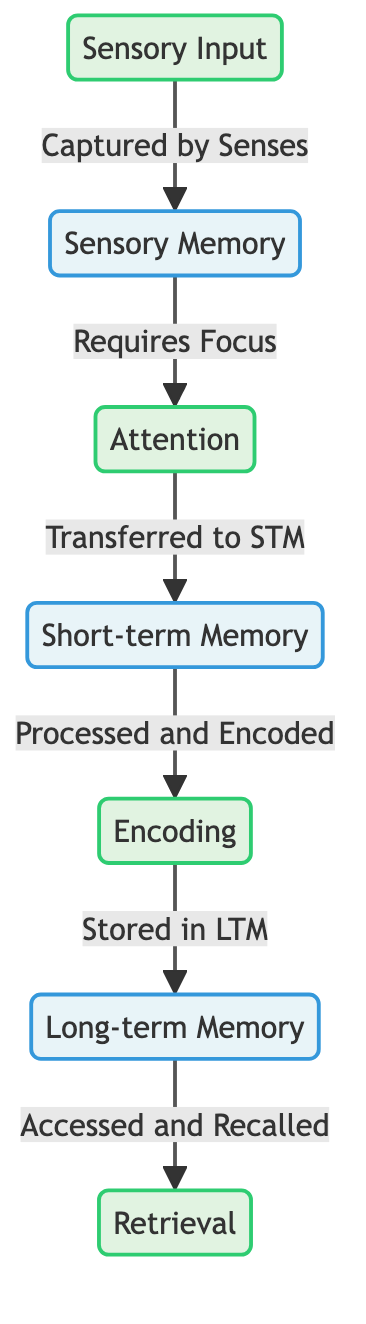What is the first step in memory formation? The diagram outlines that the first step in the process of memory formation is "Sensory Input". This node is positioned at the top of the flowchart.
Answer: Sensory Input Which stage requires focus to transfer information? The diagram indicates that "Attention" is the stage that requires focus to transfer information from Sensory Memory to Short-term Memory. This relationship is represented with an arrow pointing from Sensory Memory to Attention.
Answer: Attention How many memory types are shown in the diagram? The diagram displays two types of memory: "Sensory Memory" and "Short-term Memory", along with "Long-term Memory". That makes three types of memory in total.
Answer: Three What is the relationship between Short-term Memory and Encoding? The diagram shows an arrow indicating a direct relationship where Short-term Memory is "Processed and Encoded" leading to the Encoding stage. This means information flows from Short-term Memory to Encoding.
Answer: Processed and Encoded What occurs in the Long-term Memory stage? According to the diagram, the Long-term Memory stage is described as being "Accessed and Recalled" during the retrieval process, which follows the transfer from Encoding to Long-term Memory.
Answer: Accessed and Recalled What is required to move from Sensory Memory to Attention? The diagram specifies that the movement from Sensory Memory to Attention requires "Focus". This connection is labeled on the arrow leading to the Attention node.
Answer: Focus What is the final step in the memory process? The diagram indicates that the final step in the memory process is "Retrieval", as shown at the bottom of the flowchart, which comes after Long-term Memory.
Answer: Retrieval What is the main action associated with Encoding? The diagram states that Encoding involves the action of "Stored in LTM", indicating that the information is transferred from Encoding to Long-term Memory.
Answer: Stored in LTM What does the arrow between Attention and Short-term Memory signify? The arrow between Attention and Short-term Memory signifies that Attention is necessary for information to be transferred to Short-term Memory, highlighting the importance of focus in the memory process.
Answer: Transferred to STM 